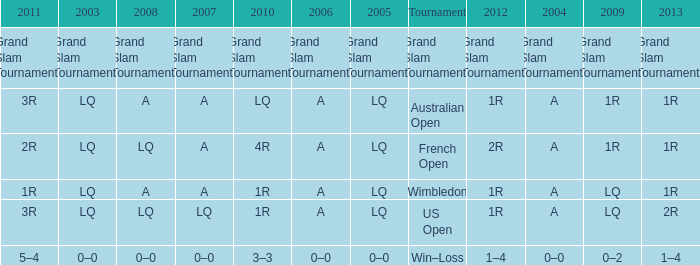Which year has a 2003 of lq? 1R, 1R, LQ, LQ. Help me parse the entirety of this table. {'header': ['2011', '2003', '2008', '2007', '2010', '2006', '2005', 'Tournament', '2012', '2004', '2009', '2013'], 'rows': [['Grand Slam Tournaments', 'Grand Slam Tournaments', 'Grand Slam Tournaments', 'Grand Slam Tournaments', 'Grand Slam Tournaments', 'Grand Slam Tournaments', 'Grand Slam Tournaments', 'Grand Slam Tournaments', 'Grand Slam Tournaments', 'Grand Slam Tournaments', 'Grand Slam Tournaments', 'Grand Slam Tournaments'], ['3R', 'LQ', 'A', 'A', 'LQ', 'A', 'LQ', 'Australian Open', '1R', 'A', '1R', '1R'], ['2R', 'LQ', 'LQ', 'A', '4R', 'A', 'LQ', 'French Open', '2R', 'A', '1R', '1R'], ['1R', 'LQ', 'A', 'A', '1R', 'A', 'LQ', 'Wimbledon', '1R', 'A', 'LQ', '1R'], ['3R', 'LQ', 'LQ', 'LQ', '1R', 'A', 'LQ', 'US Open', '1R', 'A', 'LQ', '2R'], ['5–4', '0–0', '0–0', '0–0', '3–3', '0–0', '0–0', 'Win–Loss', '1–4', '0–0', '0–2', '1–4']]} 